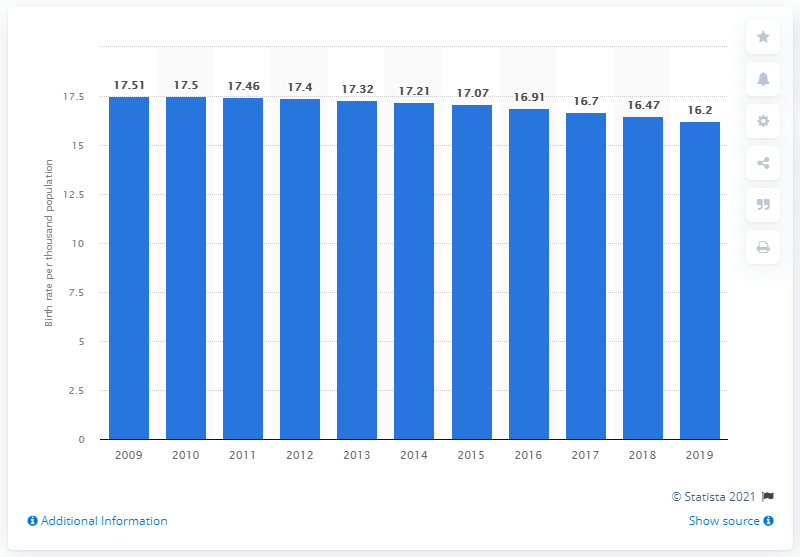Specify some key components in this picture. The crude birth rate in Grenada in 2019 was 16.2. 